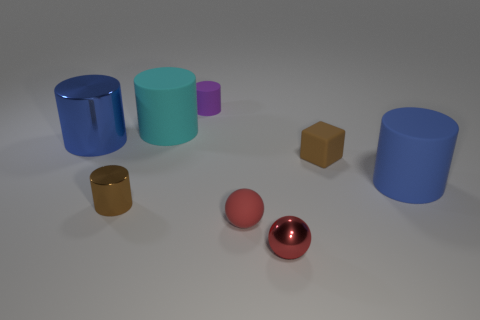What number of cylinders are on the left side of the tiny purple object and in front of the cyan cylinder?
Provide a short and direct response. 2. What shape is the purple rubber object that is the same size as the rubber sphere?
Keep it short and to the point. Cylinder. The purple cylinder is what size?
Give a very brief answer. Small. What material is the tiny cylinder that is behind the big cylinder in front of the large blue object to the left of the blue matte cylinder?
Provide a short and direct response. Rubber. What is the color of the other large thing that is the same material as the large cyan thing?
Offer a terse response. Blue. How many big cylinders are behind the blue thing that is behind the rubber cylinder that is in front of the cyan cylinder?
Offer a very short reply. 1. What is the material of the block that is the same color as the tiny shiny cylinder?
Provide a short and direct response. Rubber. Is there any other thing that is the same shape as the big cyan rubber thing?
Offer a terse response. Yes. How many things are blue objects behind the brown matte thing or tiny rubber cubes?
Provide a succinct answer. 2. There is a large cylinder in front of the block; is it the same color as the rubber ball?
Ensure brevity in your answer.  No. 